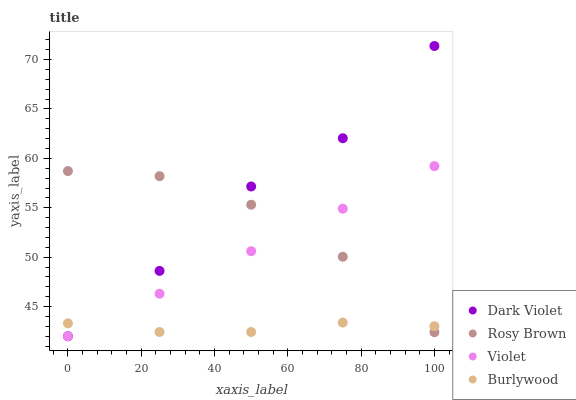Does Burlywood have the minimum area under the curve?
Answer yes or no. Yes. Does Dark Violet have the maximum area under the curve?
Answer yes or no. Yes. Does Rosy Brown have the minimum area under the curve?
Answer yes or no. No. Does Rosy Brown have the maximum area under the curve?
Answer yes or no. No. Is Violet the smoothest?
Answer yes or no. Yes. Is Dark Violet the roughest?
Answer yes or no. Yes. Is Rosy Brown the smoothest?
Answer yes or no. No. Is Rosy Brown the roughest?
Answer yes or no. No. Does Dark Violet have the lowest value?
Answer yes or no. Yes. Does Rosy Brown have the lowest value?
Answer yes or no. No. Does Dark Violet have the highest value?
Answer yes or no. Yes. Does Rosy Brown have the highest value?
Answer yes or no. No. Does Violet intersect Rosy Brown?
Answer yes or no. Yes. Is Violet less than Rosy Brown?
Answer yes or no. No. Is Violet greater than Rosy Brown?
Answer yes or no. No. 